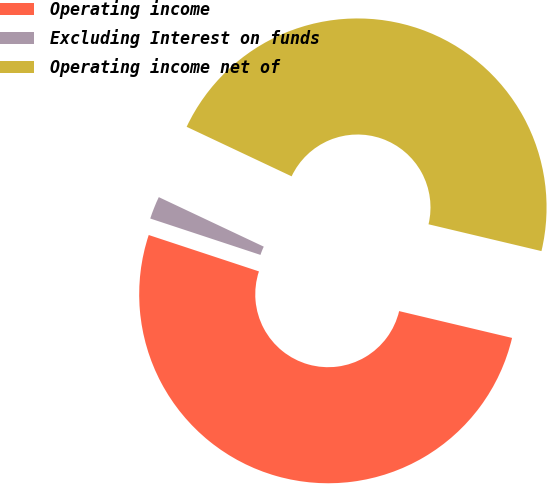Convert chart to OTSL. <chart><loc_0><loc_0><loc_500><loc_500><pie_chart><fcel>Operating income<fcel>Excluding Interest on funds<fcel>Operating income net of<nl><fcel>51.36%<fcel>1.94%<fcel>46.69%<nl></chart> 